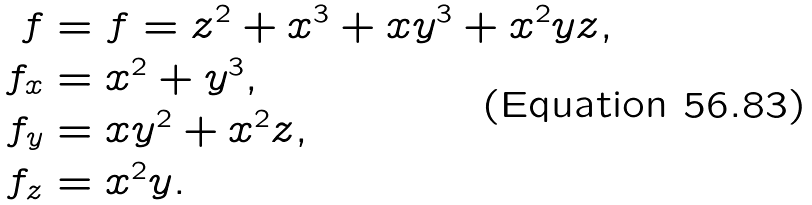Convert formula to latex. <formula><loc_0><loc_0><loc_500><loc_500>f & = f = z ^ { 2 } + x ^ { 3 } + x y ^ { 3 } + x ^ { 2 } y z , \\ f _ { x } & = x ^ { 2 } + y ^ { 3 } , \\ f _ { y } & = x y ^ { 2 } + x ^ { 2 } z , \\ f _ { z } & = x ^ { 2 } y .</formula> 